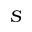Convert formula to latex. <formula><loc_0><loc_0><loc_500><loc_500>S</formula> 